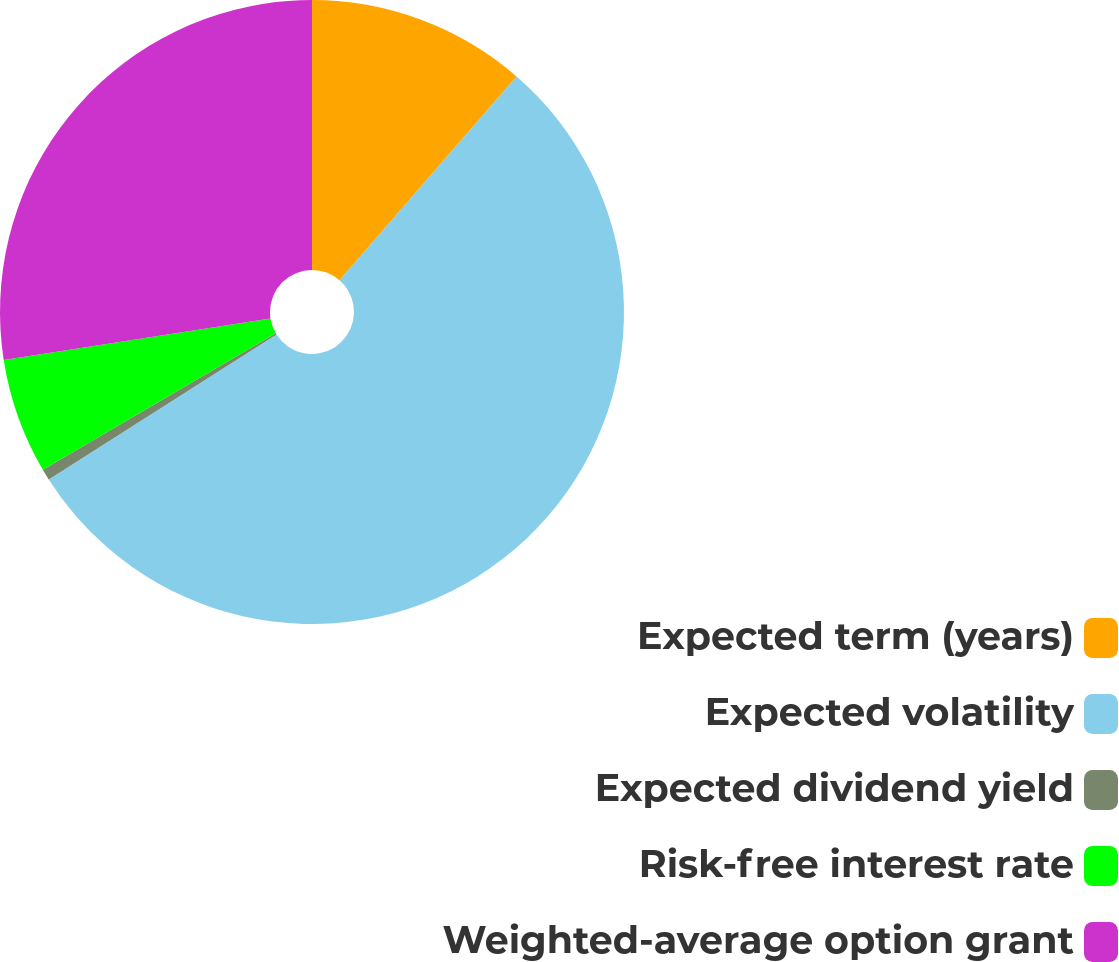Convert chart. <chart><loc_0><loc_0><loc_500><loc_500><pie_chart><fcel>Expected term (years)<fcel>Expected volatility<fcel>Expected dividend yield<fcel>Risk-free interest rate<fcel>Weighted-average option grant<nl><fcel>11.38%<fcel>54.61%<fcel>0.58%<fcel>5.98%<fcel>27.46%<nl></chart> 